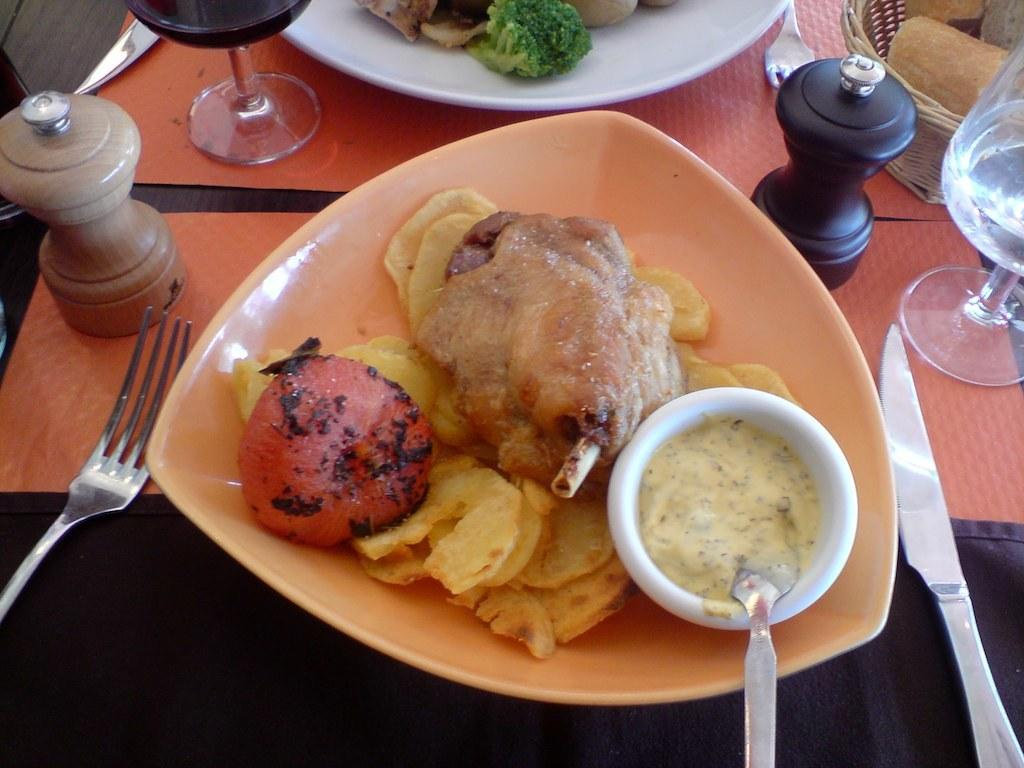What is on the plate in the image? There are food items on a plate in the image. What utensils are present on the dining table? There is a fork on the left side of the dining table and a knife on the right side of the dining table. What type of glassware is present on the dining table? Wine glasses are present on the dining table. What type of building can be seen in the background of the image? There is no building visible in the image; it only shows a plate with food items, a fork, a knife, and wine glasses on a dining table. 